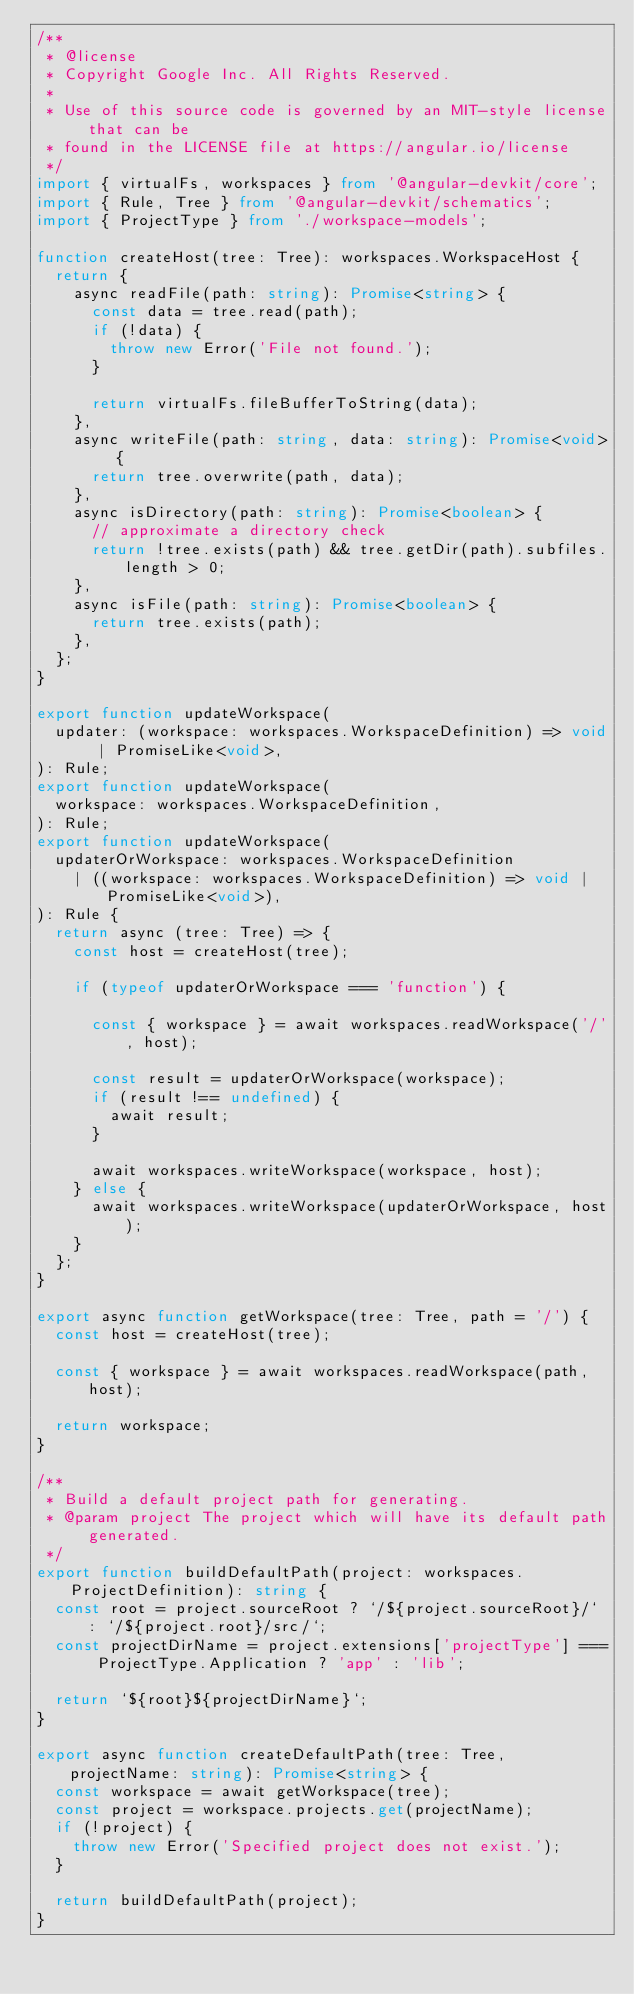<code> <loc_0><loc_0><loc_500><loc_500><_TypeScript_>/**
 * @license
 * Copyright Google Inc. All Rights Reserved.
 *
 * Use of this source code is governed by an MIT-style license that can be
 * found in the LICENSE file at https://angular.io/license
 */
import { virtualFs, workspaces } from '@angular-devkit/core';
import { Rule, Tree } from '@angular-devkit/schematics';
import { ProjectType } from './workspace-models';

function createHost(tree: Tree): workspaces.WorkspaceHost {
  return {
    async readFile(path: string): Promise<string> {
      const data = tree.read(path);
      if (!data) {
        throw new Error('File not found.');
      }

      return virtualFs.fileBufferToString(data);
    },
    async writeFile(path: string, data: string): Promise<void> {
      return tree.overwrite(path, data);
    },
    async isDirectory(path: string): Promise<boolean> {
      // approximate a directory check
      return !tree.exists(path) && tree.getDir(path).subfiles.length > 0;
    },
    async isFile(path: string): Promise<boolean> {
      return tree.exists(path);
    },
  };
}

export function updateWorkspace(
  updater: (workspace: workspaces.WorkspaceDefinition) => void | PromiseLike<void>,
): Rule;
export function updateWorkspace(
  workspace: workspaces.WorkspaceDefinition,
): Rule;
export function updateWorkspace(
  updaterOrWorkspace: workspaces.WorkspaceDefinition
    | ((workspace: workspaces.WorkspaceDefinition) => void | PromiseLike<void>),
): Rule {
  return async (tree: Tree) => {
    const host = createHost(tree);

    if (typeof updaterOrWorkspace === 'function') {

      const { workspace } = await workspaces.readWorkspace('/', host);

      const result = updaterOrWorkspace(workspace);
      if (result !== undefined) {
        await result;
      }

      await workspaces.writeWorkspace(workspace, host);
    } else {
      await workspaces.writeWorkspace(updaterOrWorkspace, host);
    }
  };
}

export async function getWorkspace(tree: Tree, path = '/') {
  const host = createHost(tree);

  const { workspace } = await workspaces.readWorkspace(path, host);

  return workspace;
}

/**
 * Build a default project path for generating.
 * @param project The project which will have its default path generated.
 */
export function buildDefaultPath(project: workspaces.ProjectDefinition): string {
  const root = project.sourceRoot ? `/${project.sourceRoot}/` : `/${project.root}/src/`;
  const projectDirName = project.extensions['projectType'] === ProjectType.Application ? 'app' : 'lib';

  return `${root}${projectDirName}`;
}

export async function createDefaultPath(tree: Tree, projectName: string): Promise<string> {
  const workspace = await getWorkspace(tree);
  const project = workspace.projects.get(projectName);
  if (!project) {
    throw new Error('Specified project does not exist.');
  }

  return buildDefaultPath(project);
}
</code> 